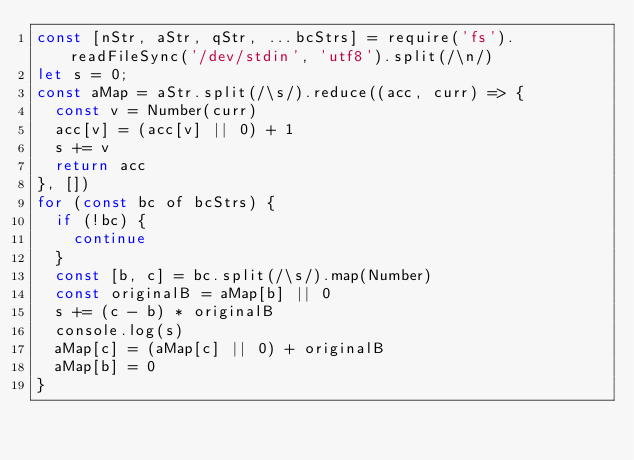Convert code to text. <code><loc_0><loc_0><loc_500><loc_500><_JavaScript_>const [nStr, aStr, qStr, ...bcStrs] = require('fs').readFileSync('/dev/stdin', 'utf8').split(/\n/)
let s = 0;
const aMap = aStr.split(/\s/).reduce((acc, curr) => {
  const v = Number(curr)
  acc[v] = (acc[v] || 0) + 1
  s += v
  return acc
}, [])
for (const bc of bcStrs) {
  if (!bc) {
    continue
  }
  const [b, c] = bc.split(/\s/).map(Number)
  const originalB = aMap[b] || 0
  s += (c - b) * originalB
  console.log(s)
  aMap[c] = (aMap[c] || 0) + originalB
  aMap[b] = 0
}</code> 